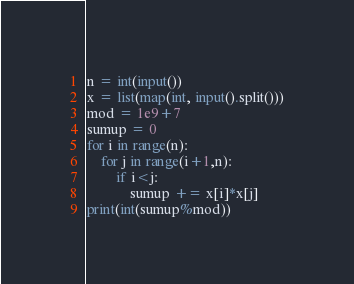Convert code to text. <code><loc_0><loc_0><loc_500><loc_500><_Python_>n = int(input())
x = list(map(int, input().split()))
mod = 1e9+7
sumup = 0
for i in range(n):
    for j in range(i+1,n):
        if i<j:
            sumup += x[i]*x[j]
print(int(sumup%mod))</code> 